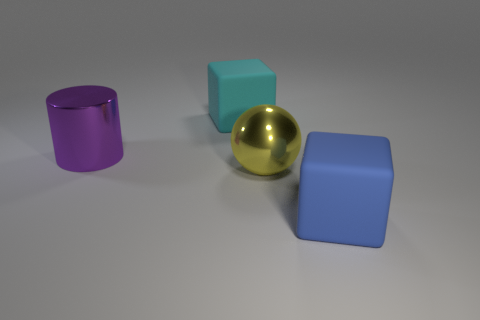Add 4 cyan objects. How many objects exist? 8 Subtract all balls. How many objects are left? 3 Add 2 purple metallic cylinders. How many purple metallic cylinders are left? 3 Add 4 large cylinders. How many large cylinders exist? 5 Subtract 0 cyan cylinders. How many objects are left? 4 Subtract all large blue things. Subtract all cyan blocks. How many objects are left? 2 